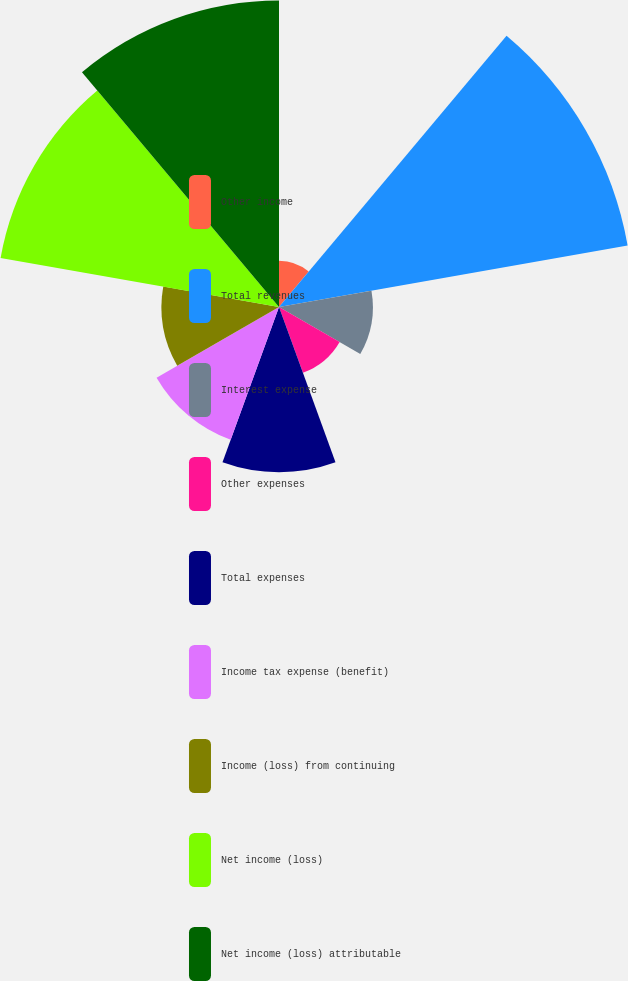Convert chart. <chart><loc_0><loc_0><loc_500><loc_500><pie_chart><fcel>Other income<fcel>Total revenues<fcel>Interest expense<fcel>Other expenses<fcel>Total expenses<fcel>Income tax expense (benefit)<fcel>Income (loss) from continuing<fcel>Net income (loss)<fcel>Net income (loss) attributable<nl><fcel>2.93%<fcel>22.44%<fcel>5.95%<fcel>4.44%<fcel>10.47%<fcel>8.96%<fcel>7.45%<fcel>17.92%<fcel>19.43%<nl></chart> 